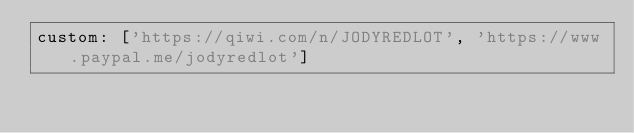<code> <loc_0><loc_0><loc_500><loc_500><_YAML_>custom: ['https://qiwi.com/n/JODYREDLOT', 'https://www.paypal.me/jodyredlot']
</code> 